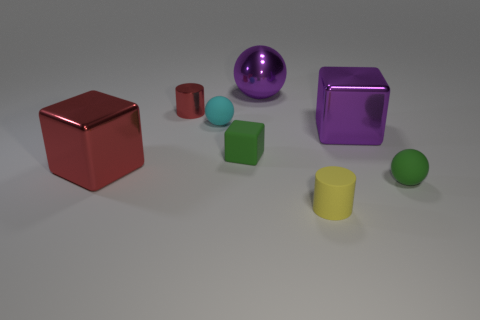There is a matte ball that is the same color as the tiny cube; what size is it?
Your answer should be compact. Small. Do the rubber block and the rubber sphere right of the small cyan sphere have the same color?
Ensure brevity in your answer.  Yes. What is the shape of the tiny yellow object that is made of the same material as the cyan object?
Your answer should be very brief. Cylinder. How many other objects are there of the same shape as the small cyan thing?
Make the answer very short. 2. What is the shape of the cyan thing behind the metallic cube to the right of the tiny matte sphere that is left of the green matte sphere?
Your response must be concise. Sphere. How many spheres are large things or tiny rubber things?
Offer a terse response. 3. Is there a big purple metal thing that is left of the shiny thing that is behind the tiny red metal thing?
Provide a short and direct response. No. Is there anything else that is the same material as the small red thing?
Your response must be concise. Yes. There is a tiny cyan object; is it the same shape as the green object that is left of the tiny green rubber ball?
Provide a short and direct response. No. What number of other things are there of the same size as the metallic cylinder?
Ensure brevity in your answer.  4. 